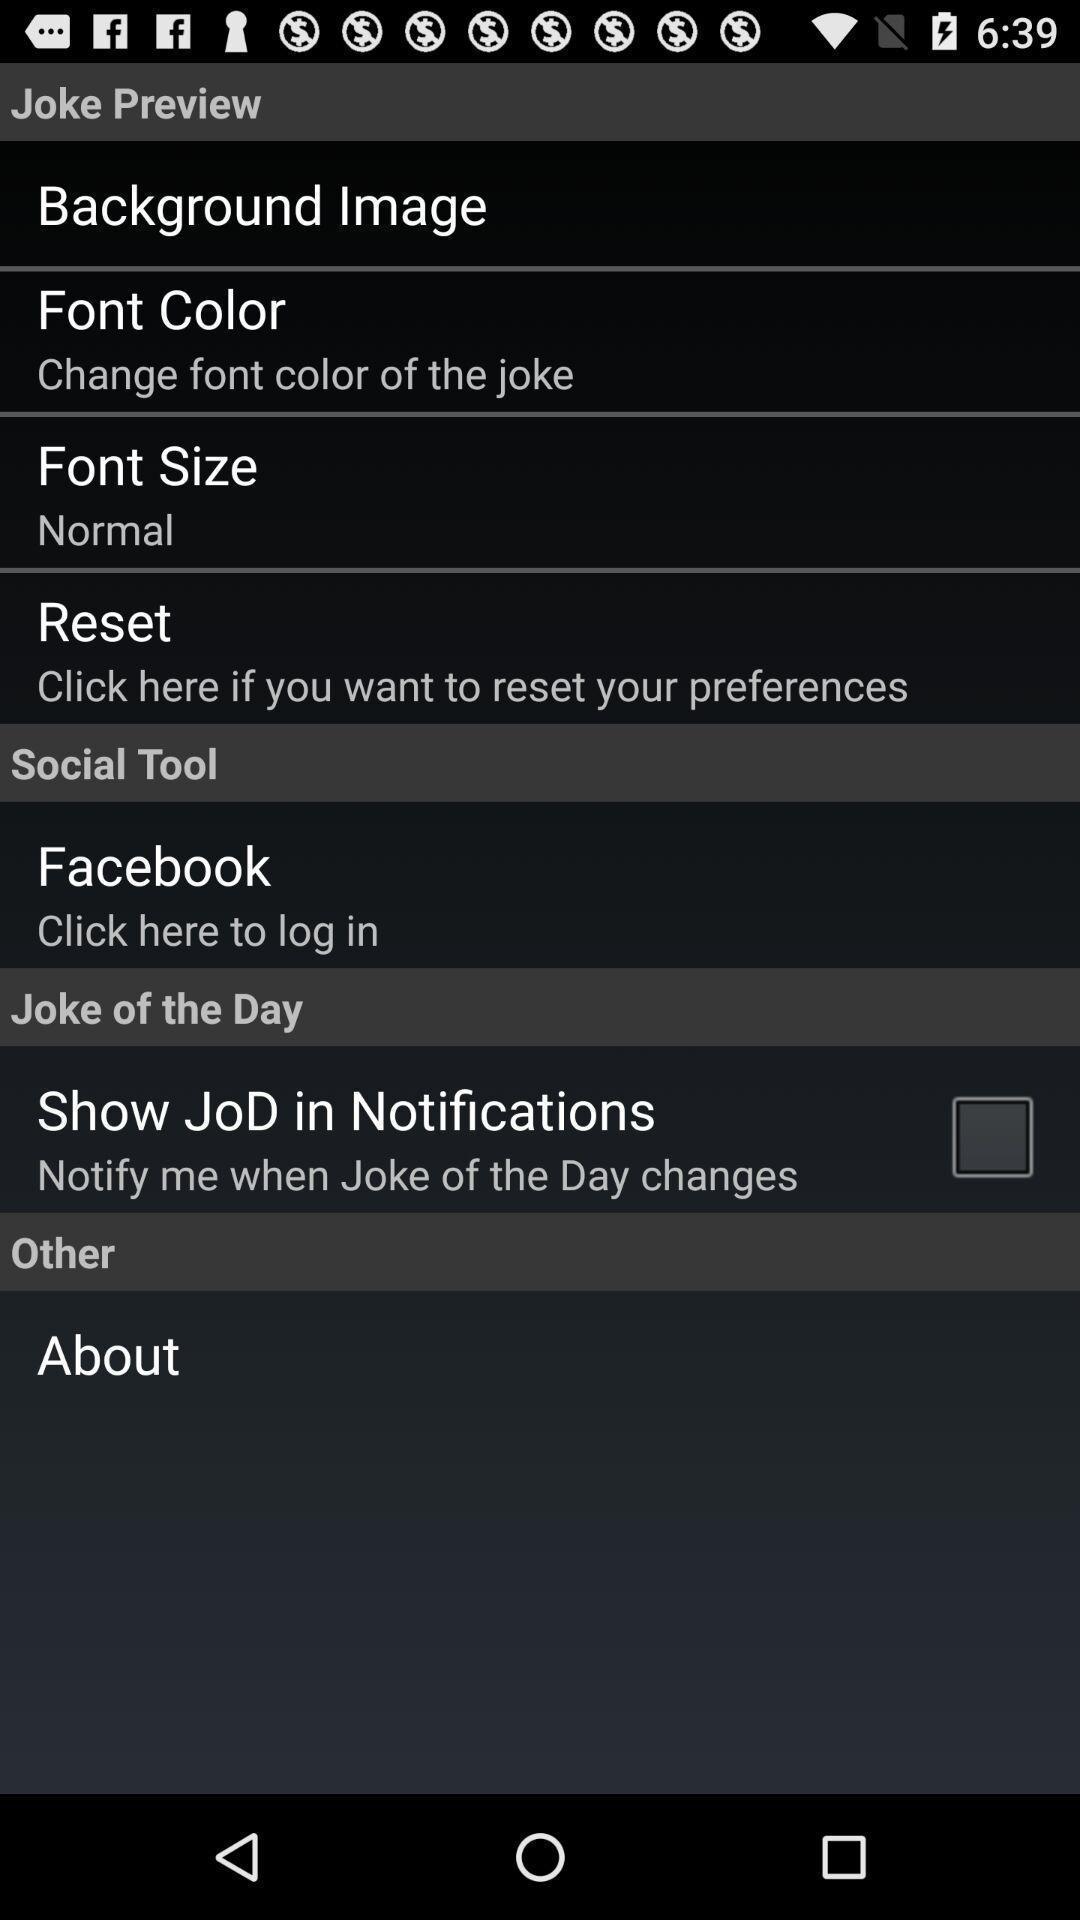Tell me what you see in this picture. Screen displaying page with options. 